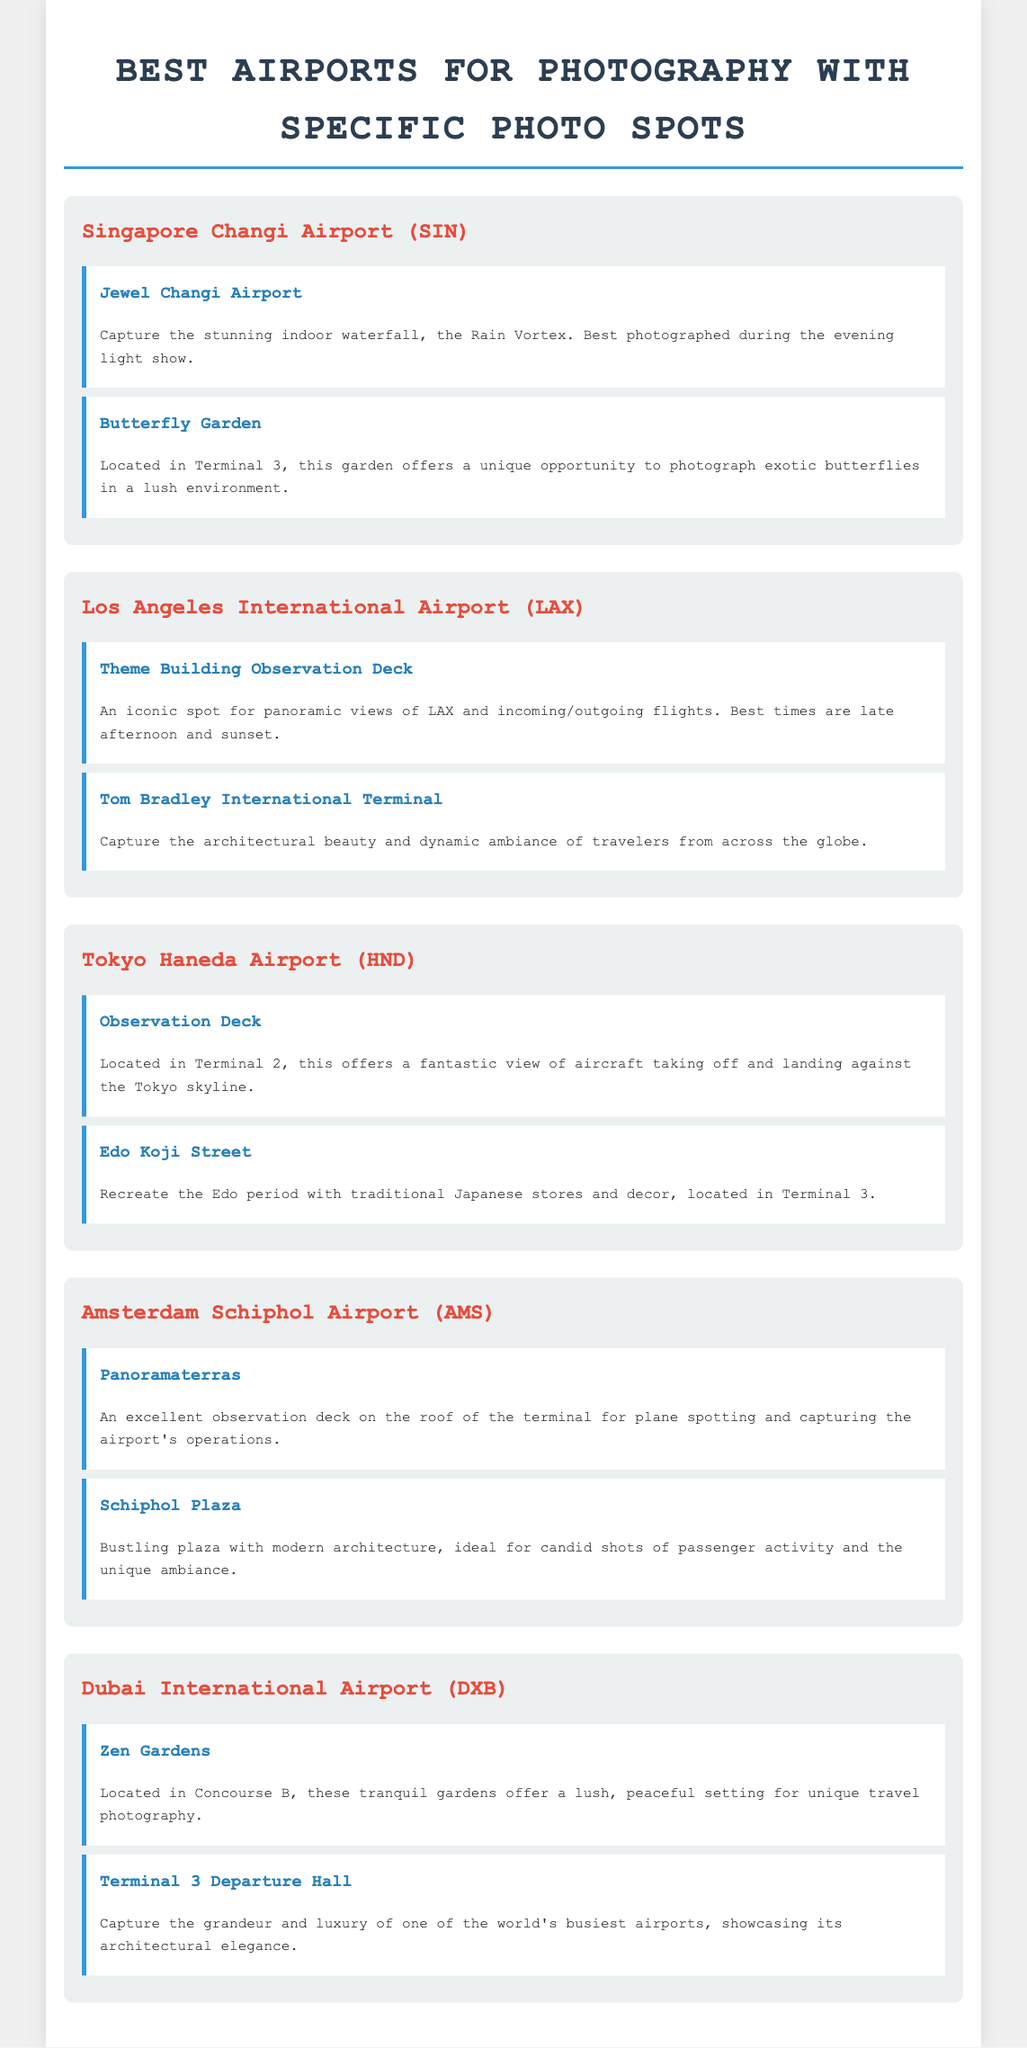What is the indoor waterfall at Singapore Changi Airport? The document describes it as the Rain Vortex located in Jewel Changi Airport, highlighting it is stunning and best photographed during the evening light show.
Answer: Rain Vortex Which airport has the Theme Building Observation Deck? The document states that the Theme Building Observation Deck is located at Los Angeles International Airport (LAX), providing an iconic panoramic view.
Answer: Los Angeles International Airport What unique environment is featured at the Butterfly Garden in Changi Airport? The document mentions that the Butterfly Garden features exotic butterflies in a lush environment, located in Terminal 3 of Singapore Changi Airport.
Answer: Lush environment What time is best for capturing photos at the Theme Building Observation Deck? According to the document, the best times for photography at that location are late afternoon and sunset.
Answer: Late afternoon and sunset Which airport's observation deck is located in Terminal 2? The document identifies that Tokyo Haneda Airport has the observation deck located in Terminal 2, providing views of aircraft against the Tokyo skyline.
Answer: Tokyo Haneda Airport How many photo spots are listed for Dubai International Airport? The document lists two specific photo spots for Dubai International Airport: the Zen Gardens and Terminal 3 Departure Hall.
Answer: Two What architectural feature is highlighted for capturing images at Terminal 3 of Dubai International Airport? The document emphasizes capturing the grandeur and luxury, showcasing the architectural elegance of one of the world's busiest airports at Terminal 3.
Answer: Architectural elegance What is the primary focus of the Panoramaterras at Amsterdam Schiphol Airport? The document states that the Panoramaterras is primarily for plane spotting and capturing the airport's operations from the observation deck on the roof.
Answer: Plane spotting Where can one recreate the Edo period in Tokyo Haneda Airport? The document indicates that Edo Koji Street is the place where one can recreate the Edo period, located in Terminal 3 of Tokyo Haneda Airport.
Answer: Edo Koji Street 